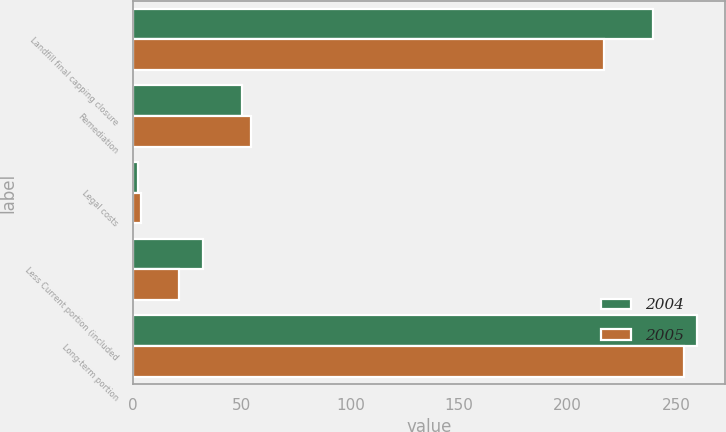<chart> <loc_0><loc_0><loc_500><loc_500><stacked_bar_chart><ecel><fcel>Landfill final capping closure<fcel>Remediation<fcel>Legal costs<fcel>Less Current portion (included<fcel>Long-term portion<nl><fcel>2004<fcel>239.5<fcel>50.3<fcel>2<fcel>32.1<fcel>259.7<nl><fcel>2005<fcel>216.8<fcel>54<fcel>3.7<fcel>21<fcel>253.5<nl></chart> 